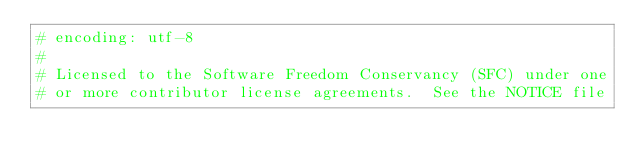<code> <loc_0><loc_0><loc_500><loc_500><_Ruby_># encoding: utf-8
#
# Licensed to the Software Freedom Conservancy (SFC) under one
# or more contributor license agreements.  See the NOTICE file</code> 